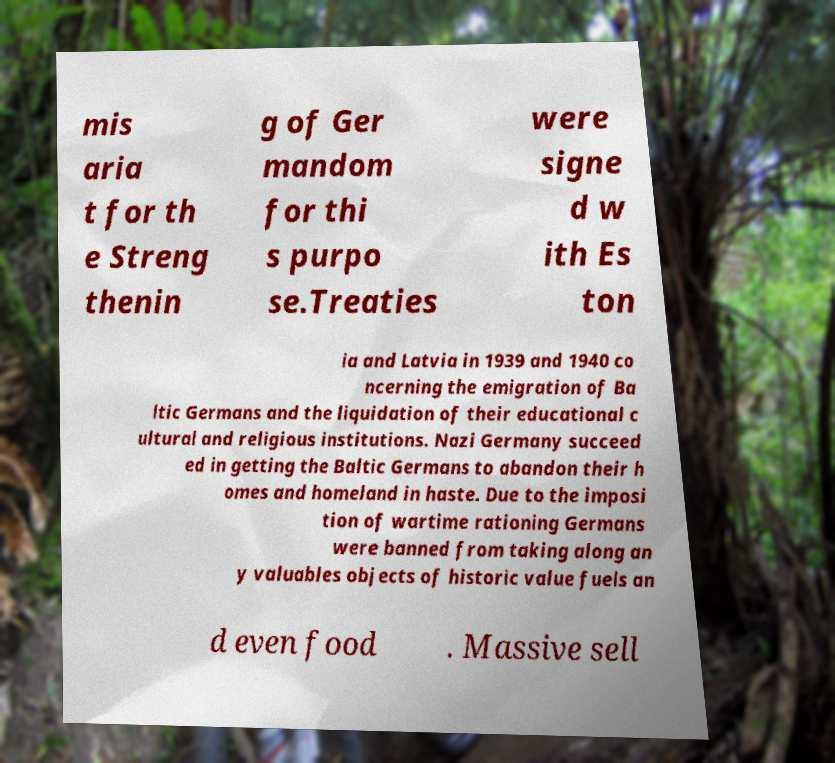There's text embedded in this image that I need extracted. Can you transcribe it verbatim? mis aria t for th e Streng thenin g of Ger mandom for thi s purpo se.Treaties were signe d w ith Es ton ia and Latvia in 1939 and 1940 co ncerning the emigration of Ba ltic Germans and the liquidation of their educational c ultural and religious institutions. Nazi Germany succeed ed in getting the Baltic Germans to abandon their h omes and homeland in haste. Due to the imposi tion of wartime rationing Germans were banned from taking along an y valuables objects of historic value fuels an d even food . Massive sell 